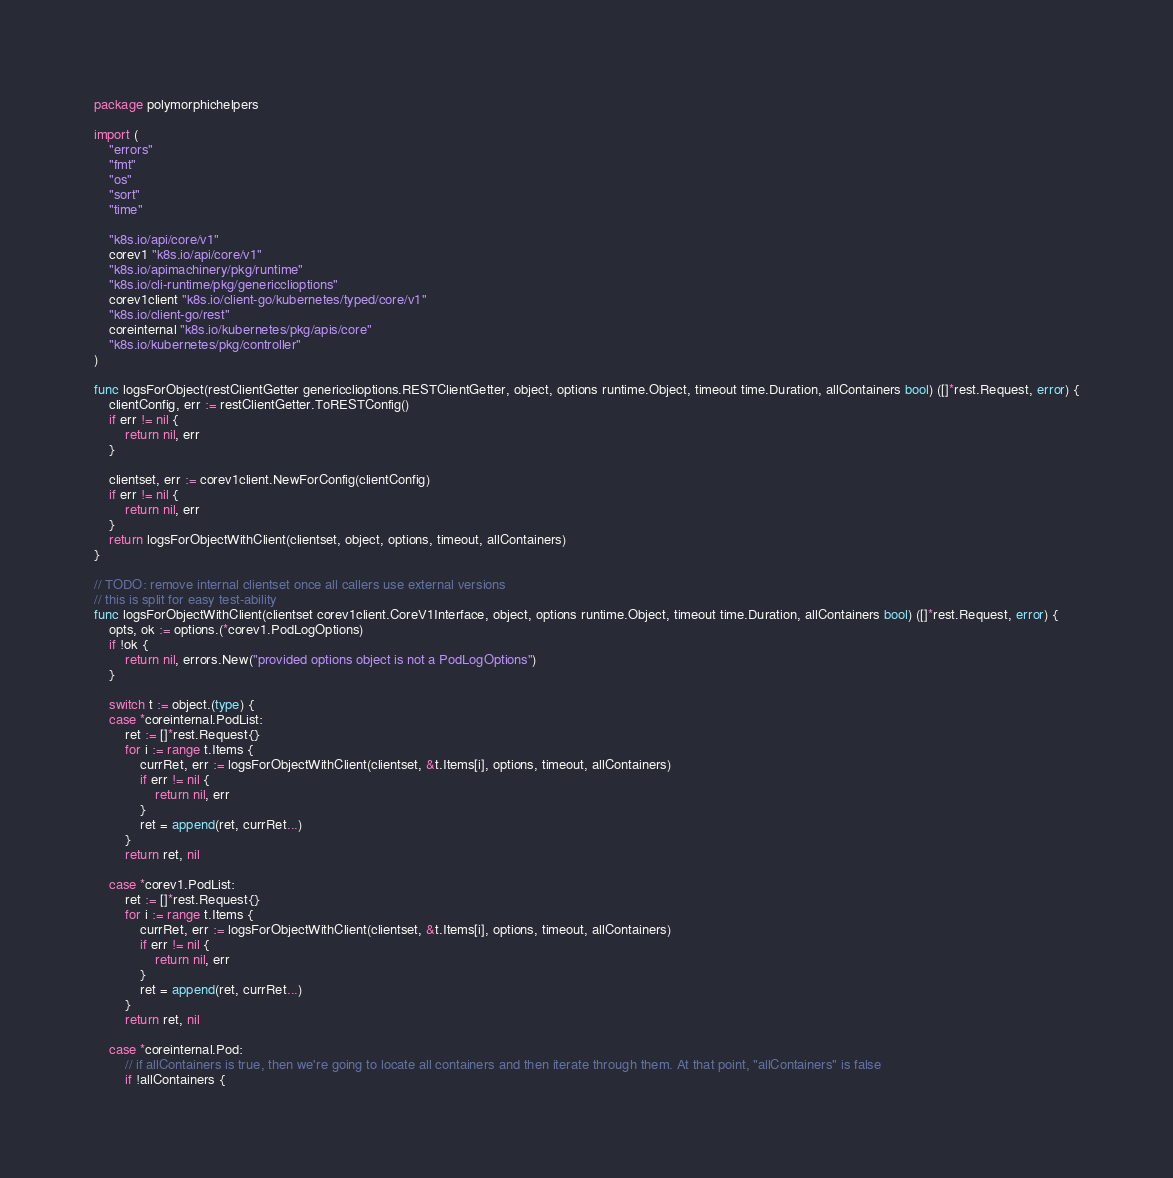<code> <loc_0><loc_0><loc_500><loc_500><_Go_>package polymorphichelpers

import (
	"errors"
	"fmt"
	"os"
	"sort"
	"time"

	"k8s.io/api/core/v1"
	corev1 "k8s.io/api/core/v1"
	"k8s.io/apimachinery/pkg/runtime"
	"k8s.io/cli-runtime/pkg/genericclioptions"
	corev1client "k8s.io/client-go/kubernetes/typed/core/v1"
	"k8s.io/client-go/rest"
	coreinternal "k8s.io/kubernetes/pkg/apis/core"
	"k8s.io/kubernetes/pkg/controller"
)

func logsForObject(restClientGetter genericclioptions.RESTClientGetter, object, options runtime.Object, timeout time.Duration, allContainers bool) ([]*rest.Request, error) {
	clientConfig, err := restClientGetter.ToRESTConfig()
	if err != nil {
		return nil, err
	}

	clientset, err := corev1client.NewForConfig(clientConfig)
	if err != nil {
		return nil, err
	}
	return logsForObjectWithClient(clientset, object, options, timeout, allContainers)
}

// TODO: remove internal clientset once all callers use external versions
// this is split for easy test-ability
func logsForObjectWithClient(clientset corev1client.CoreV1Interface, object, options runtime.Object, timeout time.Duration, allContainers bool) ([]*rest.Request, error) {
	opts, ok := options.(*corev1.PodLogOptions)
	if !ok {
		return nil, errors.New("provided options object is not a PodLogOptions")
	}

	switch t := object.(type) {
	case *coreinternal.PodList:
		ret := []*rest.Request{}
		for i := range t.Items {
			currRet, err := logsForObjectWithClient(clientset, &t.Items[i], options, timeout, allContainers)
			if err != nil {
				return nil, err
			}
			ret = append(ret, currRet...)
		}
		return ret, nil

	case *corev1.PodList:
		ret := []*rest.Request{}
		for i := range t.Items {
			currRet, err := logsForObjectWithClient(clientset, &t.Items[i], options, timeout, allContainers)
			if err != nil {
				return nil, err
			}
			ret = append(ret, currRet...)
		}
		return ret, nil

	case *coreinternal.Pod:
		// if allContainers is true, then we're going to locate all containers and then iterate through them. At that point, "allContainers" is false
		if !allContainers {</code> 